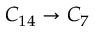<formula> <loc_0><loc_0><loc_500><loc_500>C _ { 1 4 } \to C _ { 7 }</formula> 